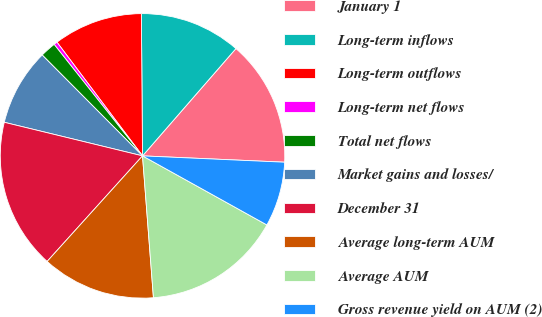<chart> <loc_0><loc_0><loc_500><loc_500><pie_chart><fcel>January 1<fcel>Long-term inflows<fcel>Long-term outflows<fcel>Long-term net flows<fcel>Total net flows<fcel>Market gains and losses/<fcel>December 31<fcel>Average long-term AUM<fcel>Average AUM<fcel>Gross revenue yield on AUM (2)<nl><fcel>14.31%<fcel>11.53%<fcel>10.14%<fcel>0.4%<fcel>1.79%<fcel>8.75%<fcel>17.1%<fcel>12.92%<fcel>15.71%<fcel>7.36%<nl></chart> 